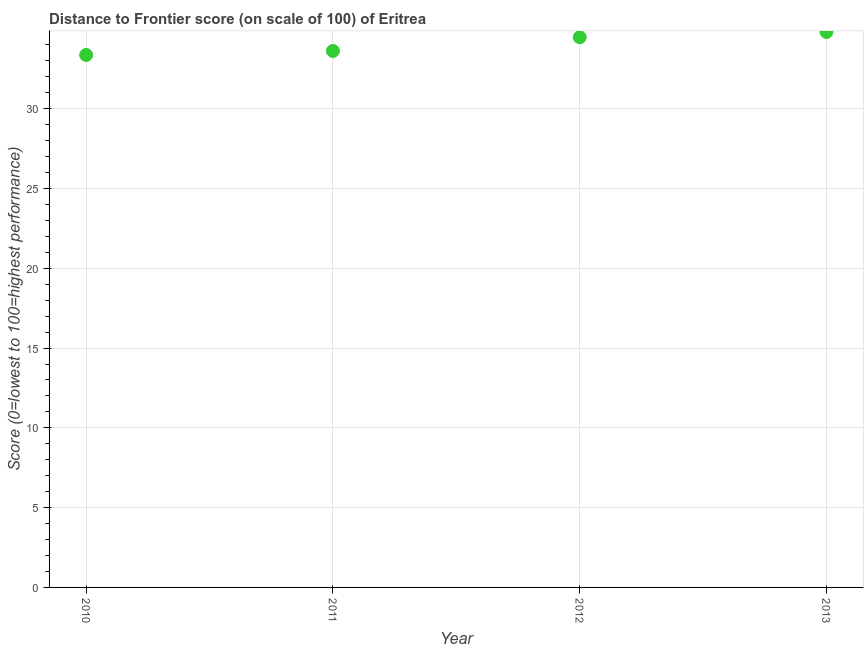What is the distance to frontier score in 2010?
Your answer should be compact. 33.37. Across all years, what is the maximum distance to frontier score?
Your answer should be compact. 34.81. Across all years, what is the minimum distance to frontier score?
Offer a very short reply. 33.37. In which year was the distance to frontier score maximum?
Your response must be concise. 2013. In which year was the distance to frontier score minimum?
Your answer should be compact. 2010. What is the sum of the distance to frontier score?
Provide a succinct answer. 136.28. What is the difference between the distance to frontier score in 2011 and 2012?
Your response must be concise. -0.86. What is the average distance to frontier score per year?
Keep it short and to the point. 34.07. What is the median distance to frontier score?
Your response must be concise. 34.05. In how many years, is the distance to frontier score greater than 24 ?
Ensure brevity in your answer.  4. Do a majority of the years between 2012 and 2010 (inclusive) have distance to frontier score greater than 26 ?
Make the answer very short. No. What is the ratio of the distance to frontier score in 2010 to that in 2012?
Provide a short and direct response. 0.97. Is the difference between the distance to frontier score in 2010 and 2011 greater than the difference between any two years?
Offer a terse response. No. What is the difference between the highest and the second highest distance to frontier score?
Your answer should be compact. 0.33. Is the sum of the distance to frontier score in 2011 and 2012 greater than the maximum distance to frontier score across all years?
Your answer should be very brief. Yes. What is the difference between the highest and the lowest distance to frontier score?
Provide a succinct answer. 1.44. Does the distance to frontier score monotonically increase over the years?
Give a very brief answer. Yes. What is the difference between two consecutive major ticks on the Y-axis?
Ensure brevity in your answer.  5. Does the graph contain any zero values?
Make the answer very short. No. What is the title of the graph?
Provide a short and direct response. Distance to Frontier score (on scale of 100) of Eritrea. What is the label or title of the X-axis?
Provide a succinct answer. Year. What is the label or title of the Y-axis?
Your answer should be compact. Score (0=lowest to 100=highest performance). What is the Score (0=lowest to 100=highest performance) in 2010?
Offer a very short reply. 33.37. What is the Score (0=lowest to 100=highest performance) in 2011?
Your response must be concise. 33.62. What is the Score (0=lowest to 100=highest performance) in 2012?
Keep it short and to the point. 34.48. What is the Score (0=lowest to 100=highest performance) in 2013?
Your response must be concise. 34.81. What is the difference between the Score (0=lowest to 100=highest performance) in 2010 and 2012?
Make the answer very short. -1.11. What is the difference between the Score (0=lowest to 100=highest performance) in 2010 and 2013?
Offer a very short reply. -1.44. What is the difference between the Score (0=lowest to 100=highest performance) in 2011 and 2012?
Offer a very short reply. -0.86. What is the difference between the Score (0=lowest to 100=highest performance) in 2011 and 2013?
Keep it short and to the point. -1.19. What is the difference between the Score (0=lowest to 100=highest performance) in 2012 and 2013?
Offer a terse response. -0.33. What is the ratio of the Score (0=lowest to 100=highest performance) in 2010 to that in 2012?
Give a very brief answer. 0.97. What is the ratio of the Score (0=lowest to 100=highest performance) in 2010 to that in 2013?
Your answer should be very brief. 0.96. What is the ratio of the Score (0=lowest to 100=highest performance) in 2011 to that in 2012?
Give a very brief answer. 0.97. What is the ratio of the Score (0=lowest to 100=highest performance) in 2011 to that in 2013?
Provide a short and direct response. 0.97. What is the ratio of the Score (0=lowest to 100=highest performance) in 2012 to that in 2013?
Offer a very short reply. 0.99. 